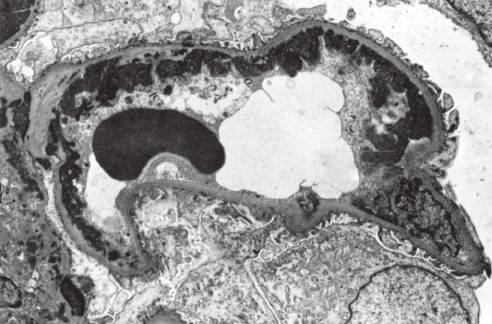do subendothelial dense deposits correspond to wire loops seen by light microscopy?
Answer the question using a single word or phrase. Yes 